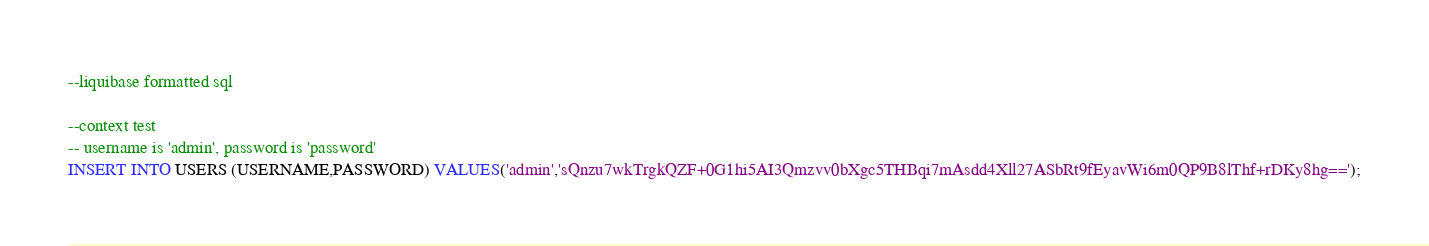<code> <loc_0><loc_0><loc_500><loc_500><_SQL_>
--liquibase formatted sql

--context test
-- username is 'admin', password is 'password'
INSERT INTO USERS (USERNAME,PASSWORD) VALUES('admin','sQnzu7wkTrgkQZF+0G1hi5AI3Qmzvv0bXgc5THBqi7mAsdd4Xll27ASbRt9fEyavWi6m0QP9B8lThf+rDKy8hg==');</code> 